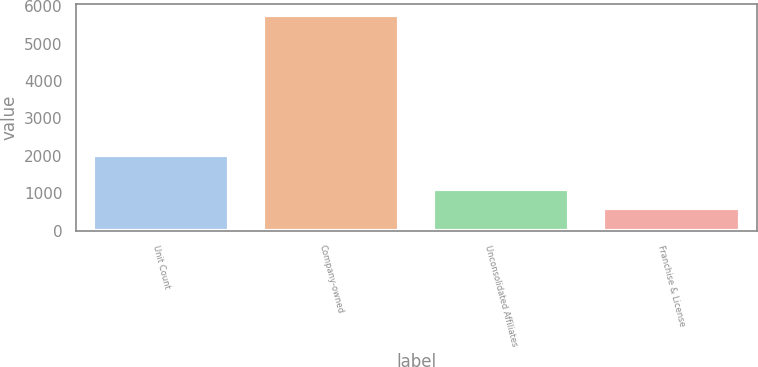Convert chart. <chart><loc_0><loc_0><loc_500><loc_500><bar_chart><fcel>Unit Count<fcel>Company-owned<fcel>Unconsolidated Affiliates<fcel>Franchise & License<nl><fcel>2015<fcel>5768<fcel>1127.6<fcel>612<nl></chart> 